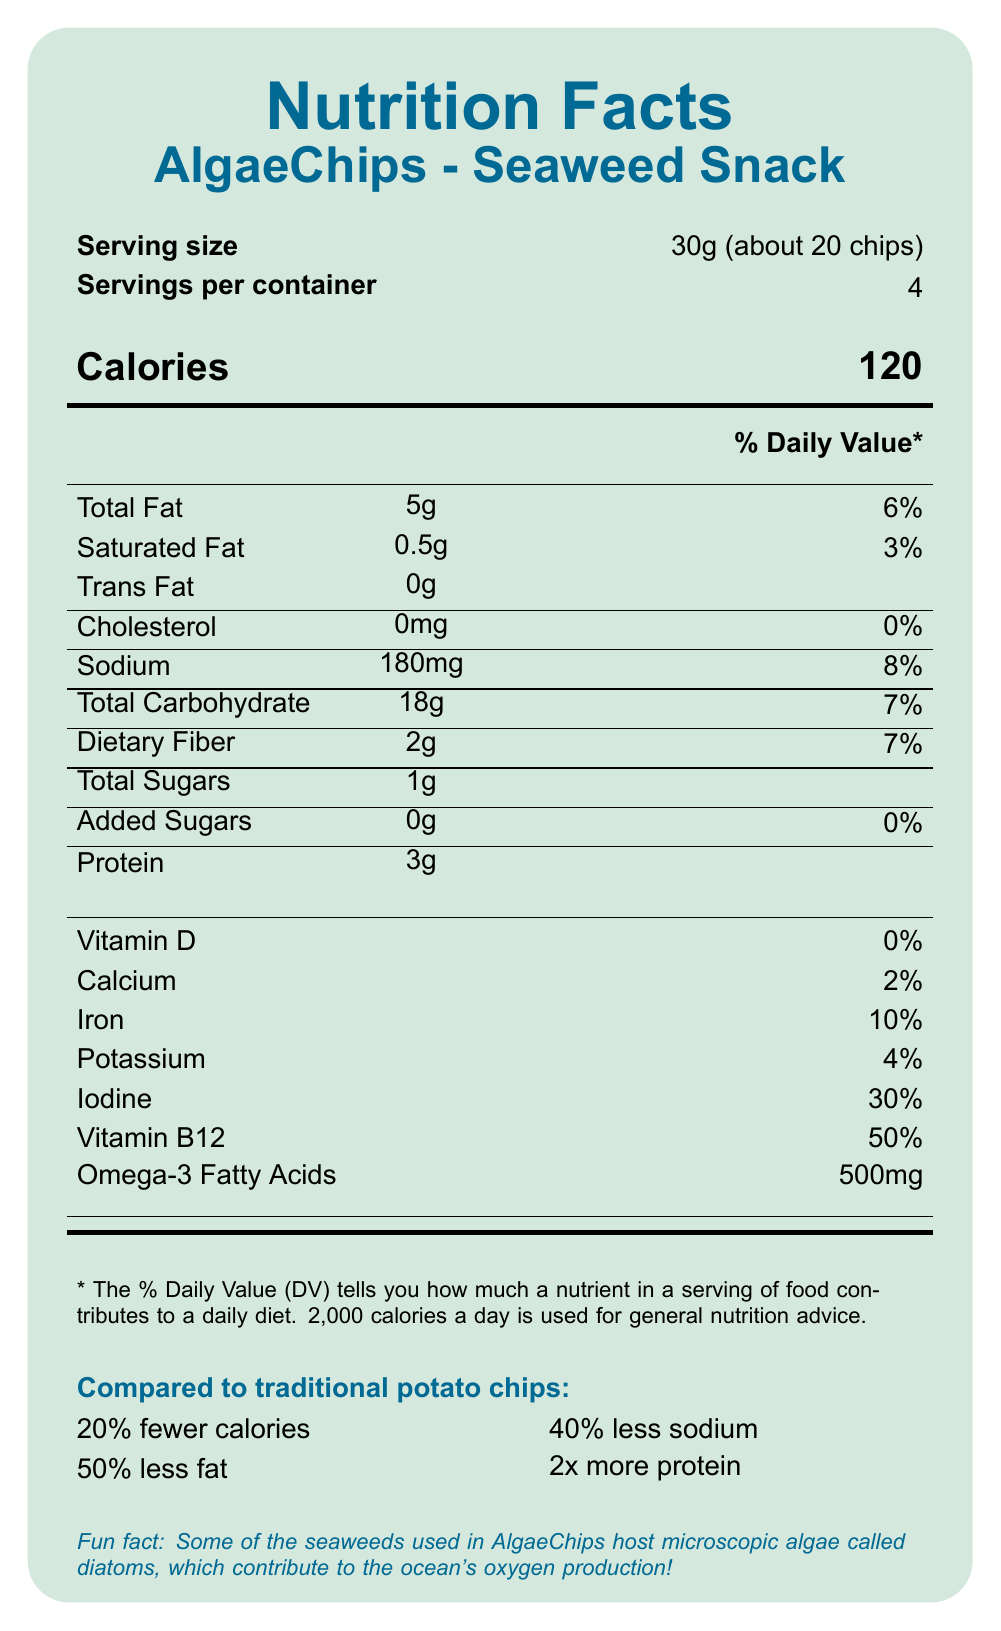what is the serving size for AlgaeChips - Seaweed Snack? The document states the serving size as 30g, which is equivalent to about 20 chips.
Answer: 30g (about 20 chips) How many calories are in one serving of AlgaeChips? The document clearly indicates that one serving contains 120 calories.
Answer: 120 What percentage of daily value does the iron content in AlgaeChips provide? It is listed in the document that the iron content in one serving of AlgaeChips provides 10% of the daily value.
Answer: 10% Which nutrient listed has the highest percentage of daily value? The percentage daily values of nutrients are listed, and Vitamin B12 has the highest at 50%.
Answer: Vitamin B12 How much omega-3 fatty acid content is there in AlgaeChips per serving? The document specifies that there are 500mg of omega-3 fatty acids per serving of AlgaeChips.
Answer: 500mg Compared to traditional potato chips, how much more dietary fiber do AlgaeChips contain? A. 50% B. 100% C. 150% D. 200% The document states that AlgaeChips contain 100% more dietary fiber compared to traditional potato chips.
Answer: B. 100% What is the main ingredient of AlgaeChips? A. Dried dulse B. Organic sunflower oil C. Sea salt D. Dried nori The first ingredient listed in the ingredients section is Dried nori, making it the main ingredient.
Answer: D. Dried nori Is there any cholesterol in AlgaeChips? The nutrition facts section shows that the cholesterol content is 0mg, indicating no cholesterol in AlgaeChips.
Answer: No Summarize the main idea of the Nutrition Facts Label for AlgaeChips - Seaweed Snack. The document outlines the nutritional profile and benefits of AlgaeChips, highlighting their health advantages compared to traditional potato chips, including key nutrients and ingredients, alongside sustainability and health claims.
Answer: The Nutrition Facts Label for AlgaeChips - Seaweed Snack provides detailed information about the serving size, calorie content, nutrient amounts, daily values, ingredients, allergen information, health claims, and sustainability info. It highlights the comparative benefits over traditional potato chips in terms of lower calories, fat, sodium, and higher protein, fiber, vitamins, and minerals. Additionally, it contains fun facts about the inclusion of microscopic algae. Does AlgaeChips contain any added sugars? The document notes that AlgaeChips contains 0g of added sugars.
Answer: No How many servings are in one container of AlgaeChips? The document mentions that there are 4 servings per container.
Answer: 4 Can we determine the specific amount of sunflower oil used in AlgaeChips from the document? The document lists organic sunflower oil as an ingredient but does not specify the exact amount used.
Answer: Cannot be determined What is the source of iodine in AlgaeChips? The document claims that seaweed is a source of iodine in AlgaeChips, stating it is an excellent source.
Answer: Seaweed How much sodium is in AlgaeChips compared to traditional potato chips? The document states that AlgaeChips contain 40% less sodium compared to traditional potato chips.
Answer: 40% less What fun fact is mentioned about the seaweeds used in AlgaeChips? The document includes a fun fact about the presence of diatoms in the seaweeds used in AlgaeChips and their role in oxygen production.
Answer: Some of the seaweeds used in AlgaeChips host microscopic algae called diatoms, which contribute to the ocean's oxygen production. 